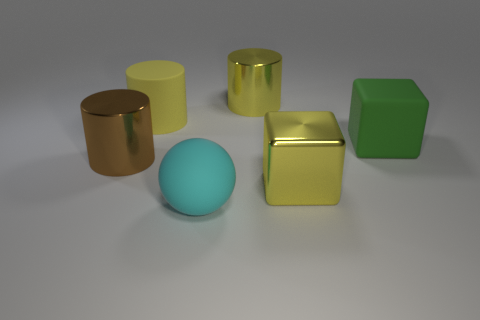What shape is the big cyan rubber thing? The big cyan object in the image is a perfect sphere, showcasing a smooth surface and even curvature typical of spherical objects. 